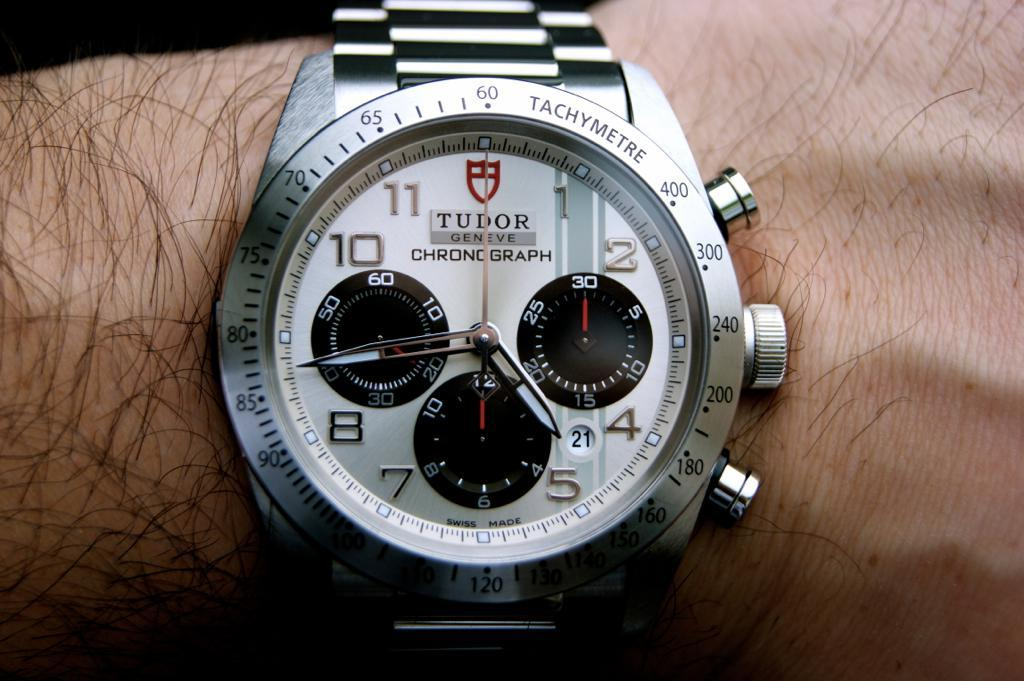<image>
Render a clear and concise summary of the photo. A silver Tudor Geneve Chronograph watch is displayed on a wrist. 